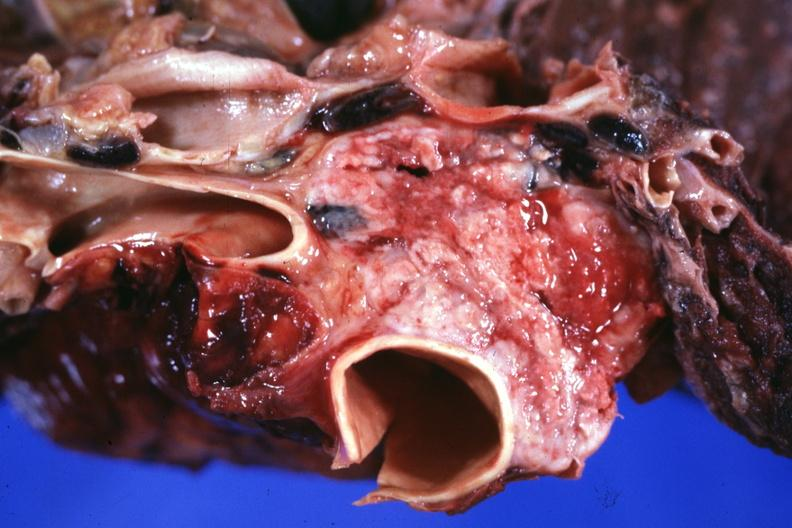does krukenberg tumor show section through mediastinum to show tumor surrounding vessels?
Answer the question using a single word or phrase. No 